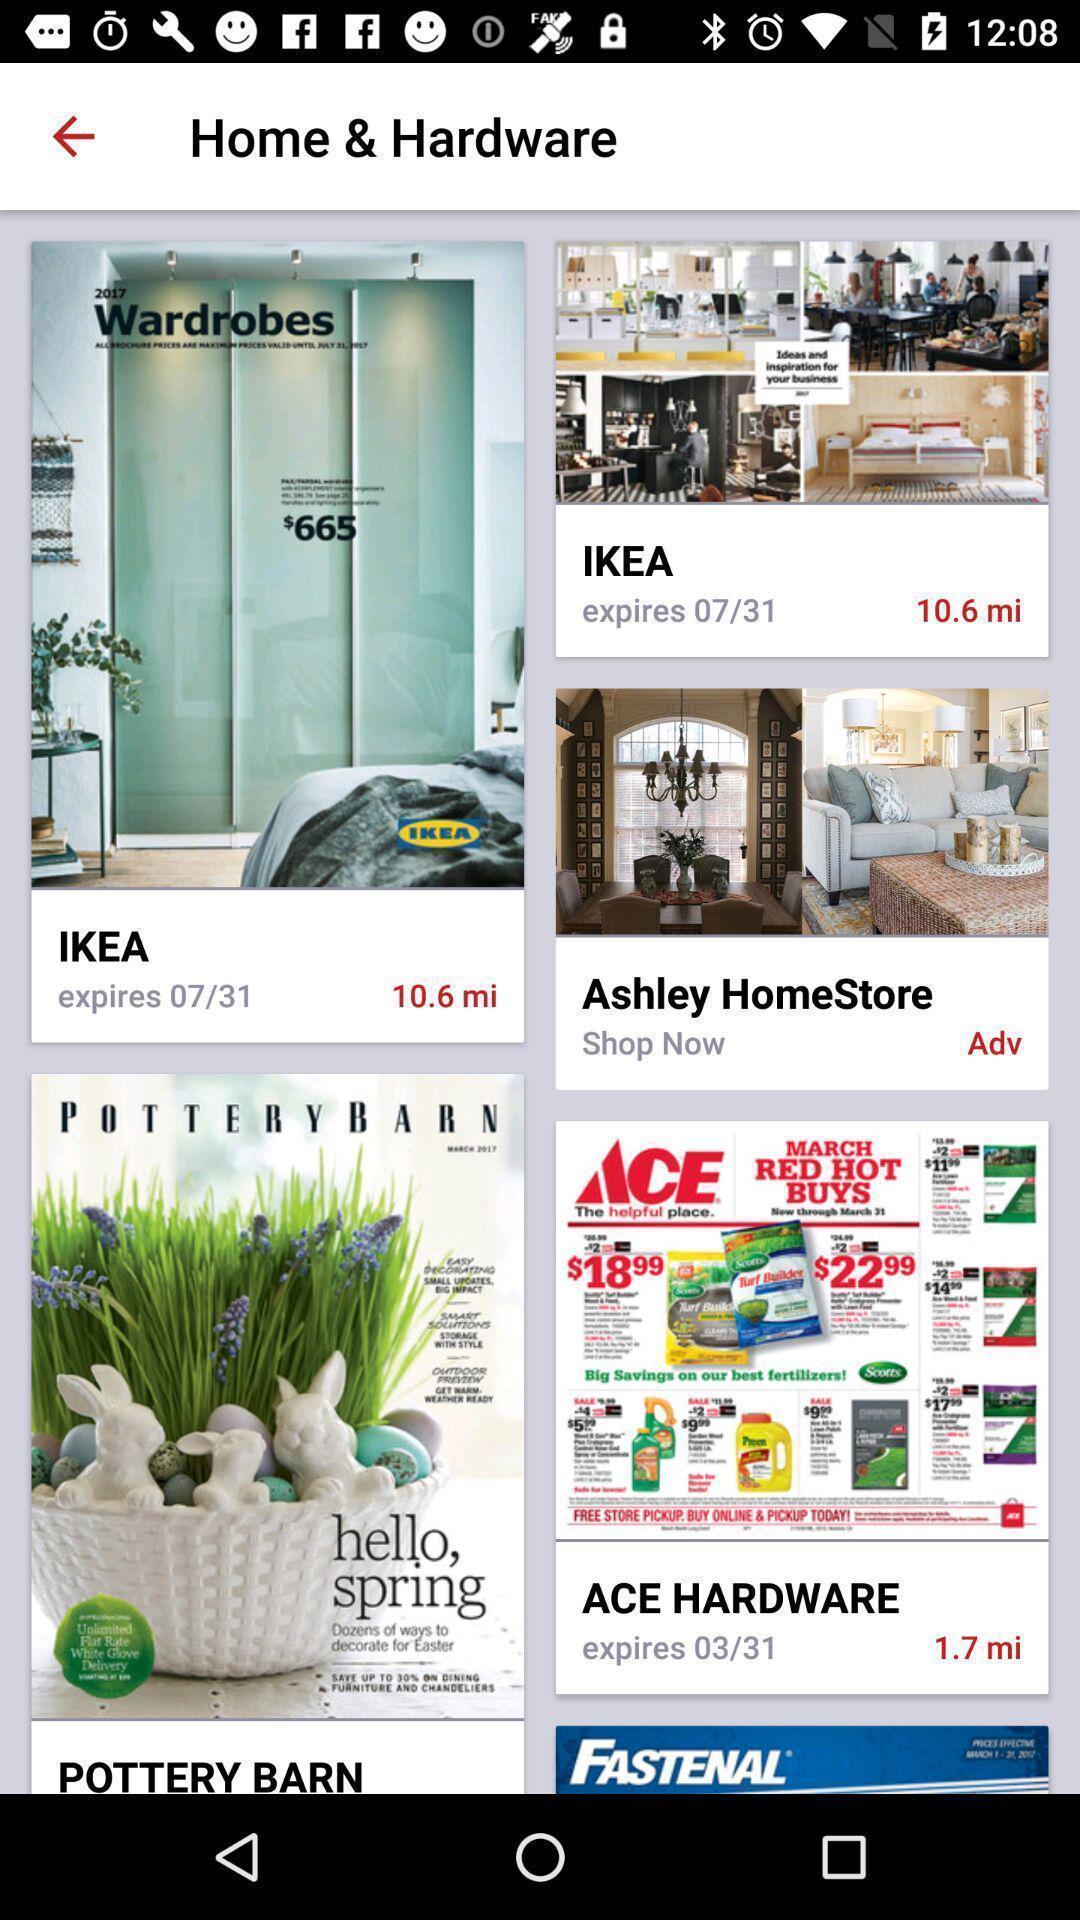What can you discern from this picture? Screen page of a shopping application. 